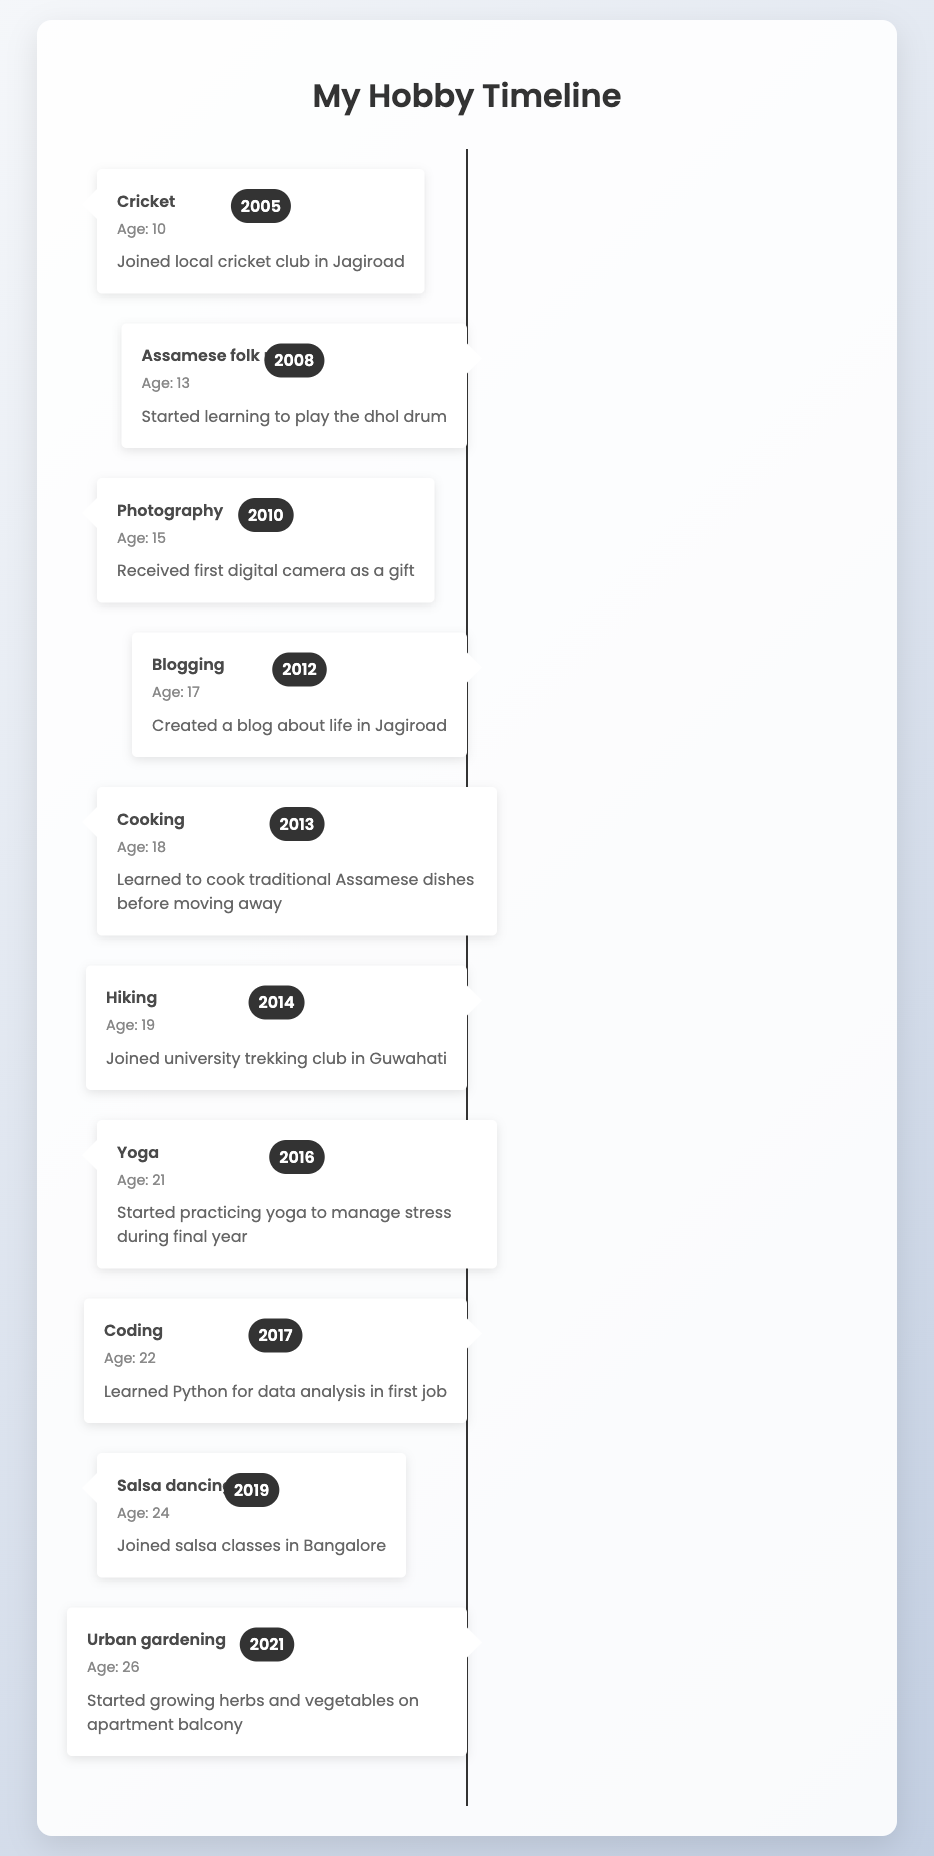What hobby did you pick up at age 10? According to the timeline, the hobby picked up at age 10 was cricket, specifically joining a local cricket club in Jagiroad.
Answer: Cricket In what year did you start learning to play the dhol drum? The data shows that learning to play the dhol drum started in 2008, when you were 13 years old.
Answer: 2008 How many hobbies were listed between 2005 and 2015? There are 6 hobbies listed between 2005 and 2015: cricket, Assamese folk music, photography, blogging, cooking, and hiking.
Answer: 6 Did you learn coding before or after you turned 21? According to the timeline, coding was learned in 2017 when you were 22, which is after turning 21.
Answer: After What is the age range during which you explored outdoor activities? Outdoor activities listed include hiking in 2014 (age 19) and yoga in 2016 (age 21). The age range is from 19 to 21, a span of 3 years.
Answer: 19 to 21 Which hobby had the earliest start date, and what does it represent? The earliest hobby listed is cricket, starting in 2005 when you were 10 years old. This represents the beginning of your engagement in sports.
Answer: Cricket How many years passed between the start of urban gardening and the blogging hobby? Urban gardening started in 2021 and blogging in 2012. The difference is 9 years (2021 - 2012).
Answer: 9 years Was salsa dancing learned before or after moving away for studies? Salsa dancing, which started in 2019, was learned after moving away, as you moved away for higher studies before 2014.
Answer: After 